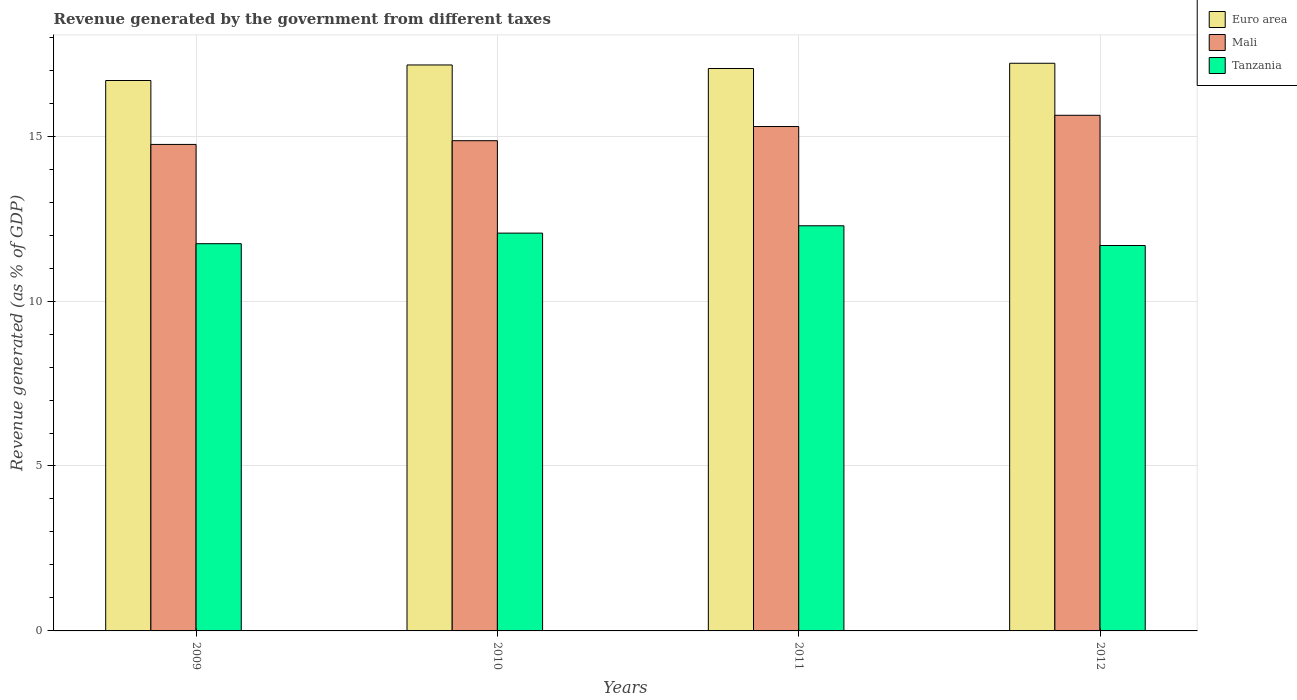Are the number of bars per tick equal to the number of legend labels?
Make the answer very short. Yes. Are the number of bars on each tick of the X-axis equal?
Your response must be concise. Yes. How many bars are there on the 2nd tick from the right?
Keep it short and to the point. 3. What is the revenue generated by the government in Euro area in 2011?
Your answer should be compact. 17.05. Across all years, what is the maximum revenue generated by the government in Tanzania?
Give a very brief answer. 12.28. Across all years, what is the minimum revenue generated by the government in Tanzania?
Ensure brevity in your answer.  11.68. What is the total revenue generated by the government in Euro area in the graph?
Ensure brevity in your answer.  68.1. What is the difference between the revenue generated by the government in Euro area in 2011 and that in 2012?
Your response must be concise. -0.16. What is the difference between the revenue generated by the government in Tanzania in 2009 and the revenue generated by the government in Mali in 2012?
Keep it short and to the point. -3.89. What is the average revenue generated by the government in Euro area per year?
Offer a very short reply. 17.03. In the year 2010, what is the difference between the revenue generated by the government in Mali and revenue generated by the government in Tanzania?
Provide a succinct answer. 2.8. In how many years, is the revenue generated by the government in Tanzania greater than 11 %?
Provide a short and direct response. 4. What is the ratio of the revenue generated by the government in Euro area in 2009 to that in 2010?
Keep it short and to the point. 0.97. Is the revenue generated by the government in Euro area in 2010 less than that in 2012?
Your answer should be very brief. Yes. Is the difference between the revenue generated by the government in Mali in 2009 and 2012 greater than the difference between the revenue generated by the government in Tanzania in 2009 and 2012?
Your response must be concise. No. What is the difference between the highest and the second highest revenue generated by the government in Mali?
Give a very brief answer. 0.34. What is the difference between the highest and the lowest revenue generated by the government in Tanzania?
Provide a short and direct response. 0.6. In how many years, is the revenue generated by the government in Mali greater than the average revenue generated by the government in Mali taken over all years?
Give a very brief answer. 2. What does the 2nd bar from the right in 2009 represents?
Offer a terse response. Mali. How many bars are there?
Provide a succinct answer. 12. Are all the bars in the graph horizontal?
Offer a very short reply. No. Does the graph contain any zero values?
Give a very brief answer. No. How are the legend labels stacked?
Keep it short and to the point. Vertical. What is the title of the graph?
Give a very brief answer. Revenue generated by the government from different taxes. Does "Middle East & North Africa (all income levels)" appear as one of the legend labels in the graph?
Your answer should be compact. No. What is the label or title of the Y-axis?
Ensure brevity in your answer.  Revenue generated (as % of GDP). What is the Revenue generated (as % of GDP) in Euro area in 2009?
Your response must be concise. 16.69. What is the Revenue generated (as % of GDP) in Mali in 2009?
Your answer should be very brief. 14.75. What is the Revenue generated (as % of GDP) of Tanzania in 2009?
Provide a succinct answer. 11.74. What is the Revenue generated (as % of GDP) of Euro area in 2010?
Ensure brevity in your answer.  17.16. What is the Revenue generated (as % of GDP) of Mali in 2010?
Your response must be concise. 14.86. What is the Revenue generated (as % of GDP) in Tanzania in 2010?
Your response must be concise. 12.06. What is the Revenue generated (as % of GDP) of Euro area in 2011?
Provide a succinct answer. 17.05. What is the Revenue generated (as % of GDP) of Mali in 2011?
Your answer should be very brief. 15.29. What is the Revenue generated (as % of GDP) of Tanzania in 2011?
Your answer should be very brief. 12.28. What is the Revenue generated (as % of GDP) in Euro area in 2012?
Keep it short and to the point. 17.21. What is the Revenue generated (as % of GDP) of Mali in 2012?
Make the answer very short. 15.63. What is the Revenue generated (as % of GDP) in Tanzania in 2012?
Your answer should be compact. 11.68. Across all years, what is the maximum Revenue generated (as % of GDP) in Euro area?
Give a very brief answer. 17.21. Across all years, what is the maximum Revenue generated (as % of GDP) in Mali?
Ensure brevity in your answer.  15.63. Across all years, what is the maximum Revenue generated (as % of GDP) in Tanzania?
Your answer should be compact. 12.28. Across all years, what is the minimum Revenue generated (as % of GDP) in Euro area?
Offer a very short reply. 16.69. Across all years, what is the minimum Revenue generated (as % of GDP) of Mali?
Keep it short and to the point. 14.75. Across all years, what is the minimum Revenue generated (as % of GDP) in Tanzania?
Provide a short and direct response. 11.68. What is the total Revenue generated (as % of GDP) in Euro area in the graph?
Your answer should be compact. 68.1. What is the total Revenue generated (as % of GDP) of Mali in the graph?
Keep it short and to the point. 60.53. What is the total Revenue generated (as % of GDP) of Tanzania in the graph?
Offer a very short reply. 47.76. What is the difference between the Revenue generated (as % of GDP) of Euro area in 2009 and that in 2010?
Provide a short and direct response. -0.47. What is the difference between the Revenue generated (as % of GDP) in Mali in 2009 and that in 2010?
Your answer should be compact. -0.11. What is the difference between the Revenue generated (as % of GDP) in Tanzania in 2009 and that in 2010?
Keep it short and to the point. -0.32. What is the difference between the Revenue generated (as % of GDP) in Euro area in 2009 and that in 2011?
Keep it short and to the point. -0.36. What is the difference between the Revenue generated (as % of GDP) of Mali in 2009 and that in 2011?
Provide a short and direct response. -0.54. What is the difference between the Revenue generated (as % of GDP) of Tanzania in 2009 and that in 2011?
Offer a terse response. -0.54. What is the difference between the Revenue generated (as % of GDP) of Euro area in 2009 and that in 2012?
Your answer should be very brief. -0.52. What is the difference between the Revenue generated (as % of GDP) in Mali in 2009 and that in 2012?
Provide a short and direct response. -0.88. What is the difference between the Revenue generated (as % of GDP) in Tanzania in 2009 and that in 2012?
Your answer should be compact. 0.06. What is the difference between the Revenue generated (as % of GDP) of Euro area in 2010 and that in 2011?
Make the answer very short. 0.11. What is the difference between the Revenue generated (as % of GDP) in Mali in 2010 and that in 2011?
Your answer should be very brief. -0.43. What is the difference between the Revenue generated (as % of GDP) of Tanzania in 2010 and that in 2011?
Offer a very short reply. -0.22. What is the difference between the Revenue generated (as % of GDP) of Euro area in 2010 and that in 2012?
Your answer should be very brief. -0.05. What is the difference between the Revenue generated (as % of GDP) in Mali in 2010 and that in 2012?
Give a very brief answer. -0.77. What is the difference between the Revenue generated (as % of GDP) in Tanzania in 2010 and that in 2012?
Provide a short and direct response. 0.38. What is the difference between the Revenue generated (as % of GDP) in Euro area in 2011 and that in 2012?
Offer a terse response. -0.16. What is the difference between the Revenue generated (as % of GDP) of Mali in 2011 and that in 2012?
Ensure brevity in your answer.  -0.34. What is the difference between the Revenue generated (as % of GDP) in Tanzania in 2011 and that in 2012?
Your answer should be very brief. 0.6. What is the difference between the Revenue generated (as % of GDP) of Euro area in 2009 and the Revenue generated (as % of GDP) of Mali in 2010?
Give a very brief answer. 1.82. What is the difference between the Revenue generated (as % of GDP) in Euro area in 2009 and the Revenue generated (as % of GDP) in Tanzania in 2010?
Keep it short and to the point. 4.63. What is the difference between the Revenue generated (as % of GDP) of Mali in 2009 and the Revenue generated (as % of GDP) of Tanzania in 2010?
Ensure brevity in your answer.  2.69. What is the difference between the Revenue generated (as % of GDP) of Euro area in 2009 and the Revenue generated (as % of GDP) of Mali in 2011?
Keep it short and to the point. 1.4. What is the difference between the Revenue generated (as % of GDP) of Euro area in 2009 and the Revenue generated (as % of GDP) of Tanzania in 2011?
Offer a terse response. 4.4. What is the difference between the Revenue generated (as % of GDP) of Mali in 2009 and the Revenue generated (as % of GDP) of Tanzania in 2011?
Provide a short and direct response. 2.47. What is the difference between the Revenue generated (as % of GDP) in Euro area in 2009 and the Revenue generated (as % of GDP) in Mali in 2012?
Keep it short and to the point. 1.05. What is the difference between the Revenue generated (as % of GDP) of Euro area in 2009 and the Revenue generated (as % of GDP) of Tanzania in 2012?
Your response must be concise. 5. What is the difference between the Revenue generated (as % of GDP) of Mali in 2009 and the Revenue generated (as % of GDP) of Tanzania in 2012?
Make the answer very short. 3.06. What is the difference between the Revenue generated (as % of GDP) of Euro area in 2010 and the Revenue generated (as % of GDP) of Mali in 2011?
Offer a terse response. 1.87. What is the difference between the Revenue generated (as % of GDP) of Euro area in 2010 and the Revenue generated (as % of GDP) of Tanzania in 2011?
Give a very brief answer. 4.88. What is the difference between the Revenue generated (as % of GDP) of Mali in 2010 and the Revenue generated (as % of GDP) of Tanzania in 2011?
Ensure brevity in your answer.  2.58. What is the difference between the Revenue generated (as % of GDP) in Euro area in 2010 and the Revenue generated (as % of GDP) in Mali in 2012?
Provide a succinct answer. 1.53. What is the difference between the Revenue generated (as % of GDP) of Euro area in 2010 and the Revenue generated (as % of GDP) of Tanzania in 2012?
Keep it short and to the point. 5.47. What is the difference between the Revenue generated (as % of GDP) of Mali in 2010 and the Revenue generated (as % of GDP) of Tanzania in 2012?
Provide a succinct answer. 3.18. What is the difference between the Revenue generated (as % of GDP) in Euro area in 2011 and the Revenue generated (as % of GDP) in Mali in 2012?
Your answer should be very brief. 1.42. What is the difference between the Revenue generated (as % of GDP) of Euro area in 2011 and the Revenue generated (as % of GDP) of Tanzania in 2012?
Your answer should be compact. 5.37. What is the difference between the Revenue generated (as % of GDP) of Mali in 2011 and the Revenue generated (as % of GDP) of Tanzania in 2012?
Keep it short and to the point. 3.61. What is the average Revenue generated (as % of GDP) in Euro area per year?
Ensure brevity in your answer.  17.03. What is the average Revenue generated (as % of GDP) of Mali per year?
Make the answer very short. 15.13. What is the average Revenue generated (as % of GDP) in Tanzania per year?
Make the answer very short. 11.94. In the year 2009, what is the difference between the Revenue generated (as % of GDP) of Euro area and Revenue generated (as % of GDP) of Mali?
Keep it short and to the point. 1.94. In the year 2009, what is the difference between the Revenue generated (as % of GDP) of Euro area and Revenue generated (as % of GDP) of Tanzania?
Give a very brief answer. 4.95. In the year 2009, what is the difference between the Revenue generated (as % of GDP) in Mali and Revenue generated (as % of GDP) in Tanzania?
Provide a succinct answer. 3.01. In the year 2010, what is the difference between the Revenue generated (as % of GDP) of Euro area and Revenue generated (as % of GDP) of Mali?
Provide a succinct answer. 2.3. In the year 2010, what is the difference between the Revenue generated (as % of GDP) in Euro area and Revenue generated (as % of GDP) in Tanzania?
Provide a succinct answer. 5.1. In the year 2010, what is the difference between the Revenue generated (as % of GDP) in Mali and Revenue generated (as % of GDP) in Tanzania?
Keep it short and to the point. 2.8. In the year 2011, what is the difference between the Revenue generated (as % of GDP) of Euro area and Revenue generated (as % of GDP) of Mali?
Keep it short and to the point. 1.76. In the year 2011, what is the difference between the Revenue generated (as % of GDP) in Euro area and Revenue generated (as % of GDP) in Tanzania?
Your response must be concise. 4.77. In the year 2011, what is the difference between the Revenue generated (as % of GDP) of Mali and Revenue generated (as % of GDP) of Tanzania?
Provide a succinct answer. 3.01. In the year 2012, what is the difference between the Revenue generated (as % of GDP) in Euro area and Revenue generated (as % of GDP) in Mali?
Keep it short and to the point. 1.58. In the year 2012, what is the difference between the Revenue generated (as % of GDP) of Euro area and Revenue generated (as % of GDP) of Tanzania?
Offer a very short reply. 5.53. In the year 2012, what is the difference between the Revenue generated (as % of GDP) of Mali and Revenue generated (as % of GDP) of Tanzania?
Give a very brief answer. 3.95. What is the ratio of the Revenue generated (as % of GDP) of Euro area in 2009 to that in 2010?
Provide a succinct answer. 0.97. What is the ratio of the Revenue generated (as % of GDP) of Mali in 2009 to that in 2010?
Your answer should be very brief. 0.99. What is the ratio of the Revenue generated (as % of GDP) of Tanzania in 2009 to that in 2010?
Offer a terse response. 0.97. What is the ratio of the Revenue generated (as % of GDP) of Euro area in 2009 to that in 2011?
Your answer should be very brief. 0.98. What is the ratio of the Revenue generated (as % of GDP) in Mali in 2009 to that in 2011?
Offer a terse response. 0.96. What is the ratio of the Revenue generated (as % of GDP) in Tanzania in 2009 to that in 2011?
Ensure brevity in your answer.  0.96. What is the ratio of the Revenue generated (as % of GDP) of Euro area in 2009 to that in 2012?
Your answer should be compact. 0.97. What is the ratio of the Revenue generated (as % of GDP) in Mali in 2009 to that in 2012?
Your response must be concise. 0.94. What is the ratio of the Revenue generated (as % of GDP) of Tanzania in 2009 to that in 2012?
Provide a succinct answer. 1. What is the ratio of the Revenue generated (as % of GDP) in Euro area in 2010 to that in 2011?
Give a very brief answer. 1.01. What is the ratio of the Revenue generated (as % of GDP) of Mali in 2010 to that in 2011?
Provide a succinct answer. 0.97. What is the ratio of the Revenue generated (as % of GDP) of Tanzania in 2010 to that in 2011?
Offer a very short reply. 0.98. What is the ratio of the Revenue generated (as % of GDP) of Mali in 2010 to that in 2012?
Keep it short and to the point. 0.95. What is the ratio of the Revenue generated (as % of GDP) of Tanzania in 2010 to that in 2012?
Make the answer very short. 1.03. What is the ratio of the Revenue generated (as % of GDP) in Euro area in 2011 to that in 2012?
Give a very brief answer. 0.99. What is the ratio of the Revenue generated (as % of GDP) of Mali in 2011 to that in 2012?
Provide a short and direct response. 0.98. What is the ratio of the Revenue generated (as % of GDP) in Tanzania in 2011 to that in 2012?
Your response must be concise. 1.05. What is the difference between the highest and the second highest Revenue generated (as % of GDP) in Euro area?
Your answer should be compact. 0.05. What is the difference between the highest and the second highest Revenue generated (as % of GDP) in Mali?
Offer a terse response. 0.34. What is the difference between the highest and the second highest Revenue generated (as % of GDP) in Tanzania?
Offer a terse response. 0.22. What is the difference between the highest and the lowest Revenue generated (as % of GDP) of Euro area?
Your answer should be very brief. 0.52. What is the difference between the highest and the lowest Revenue generated (as % of GDP) of Mali?
Your answer should be very brief. 0.88. What is the difference between the highest and the lowest Revenue generated (as % of GDP) of Tanzania?
Offer a very short reply. 0.6. 